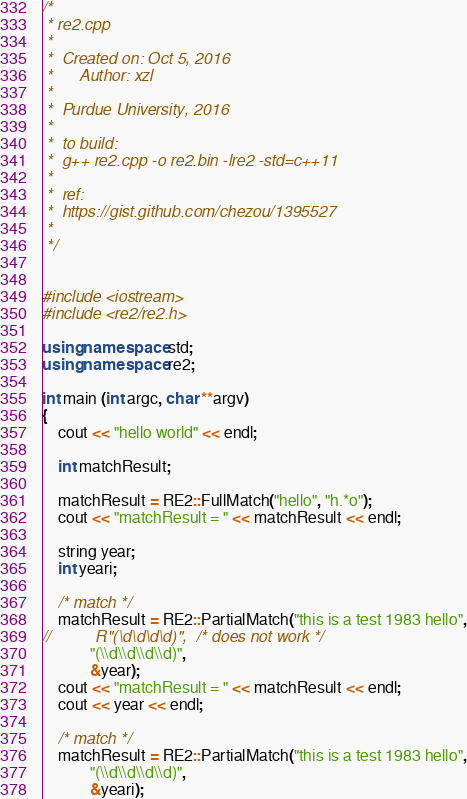Convert code to text. <code><loc_0><loc_0><loc_500><loc_500><_C++_>/*
 * re2.cpp
 *
 *  Created on: Oct 5, 2016
 *      Author: xzl
 *
 *  Purdue University, 2016
 *
 *  to build:
 *  g++ re2.cpp -o re2.bin -lre2 -std=c++11
 *
 *  ref:
 *  https://gist.github.com/chezou/1395527
 *
 */


#include <iostream>
#include <re2/re2.h>

using namespace std;
using namespace re2;

int main (int argc, char **argv)
{
    cout << "hello world" << endl;

    int matchResult;

    matchResult = RE2::FullMatch("hello", "h.*o");
    cout << "matchResult = " << matchResult << endl;

    string year;
    int yeari;

    /* match */
    matchResult = RE2::PartialMatch("this is a test 1983 hello",
//    		R"(\d\d\d\d)",  /* does not work */
    		"(\\d\\d\\d\\d)",
    		&year);
    cout << "matchResult = " << matchResult << endl;
    cout << year << endl;

    /* match */
    matchResult = RE2::PartialMatch("this is a test 1983 hello",
    		"(\\d\\d\\d\\d)",
    		&yeari);</code> 